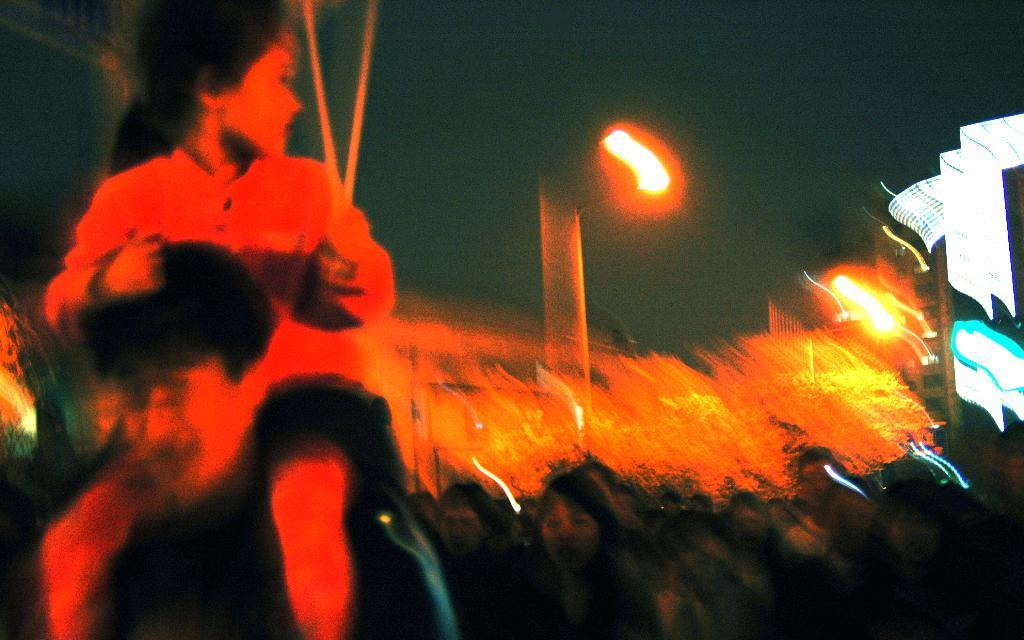How many people are on the left side of the image? There are two people on the left side of the image. What can be seen on the right side of the image? There are two groups of people on the right side of the image. What type of structures are visible in the image? There are buildings visible in the image. What is used to illuminate the scene in the image? Lights are present in the image. What is visible at the top of the image? The sky is visible at the top of the image. What type of boundary can be seen between the two groups of people on the right side of the image? There is no boundary visible between the two groups of people on the right side of the image. Can you tell me how many cows are present in the image? There are no cows present in the image. 